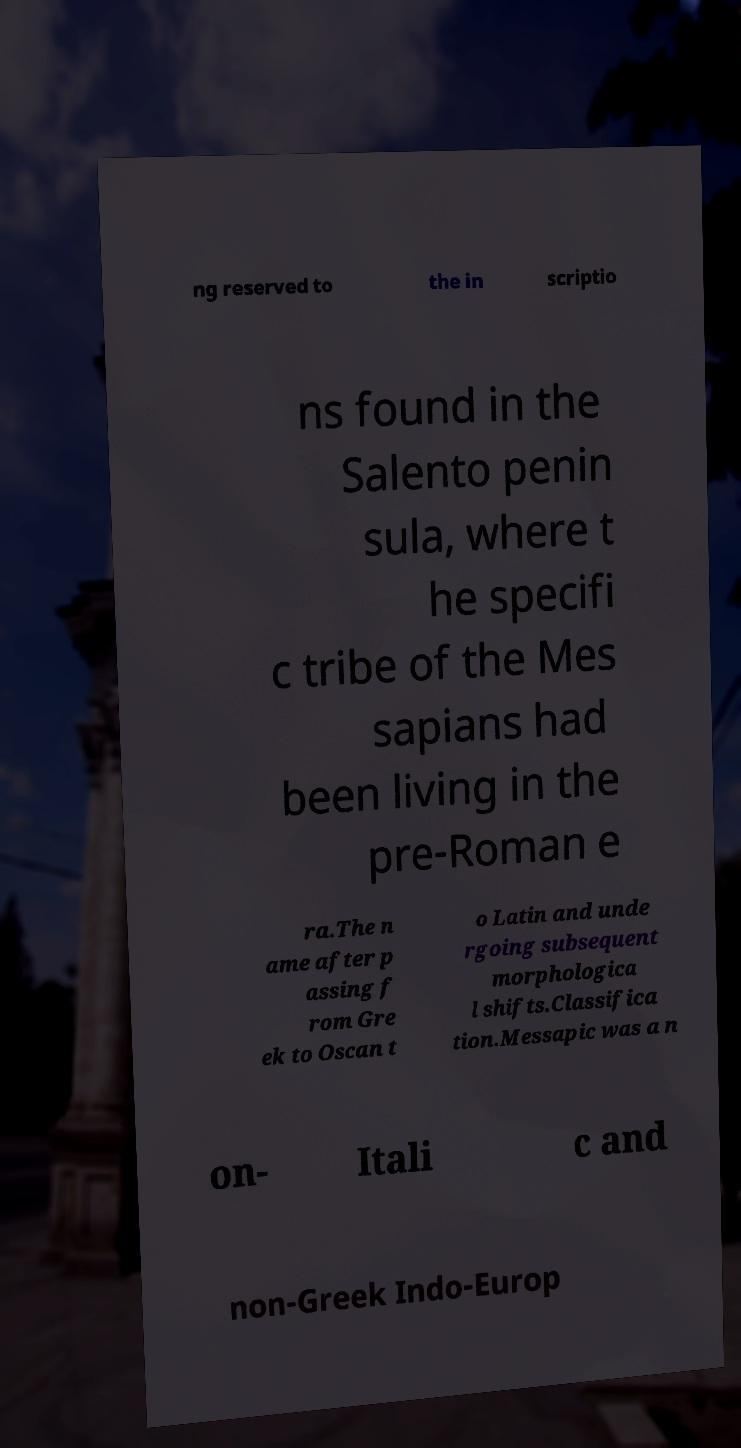What messages or text are displayed in this image? I need them in a readable, typed format. ng reserved to the in scriptio ns found in the Salento penin sula, where t he specifi c tribe of the Mes sapians had been living in the pre-Roman e ra.The n ame after p assing f rom Gre ek to Oscan t o Latin and unde rgoing subsequent morphologica l shifts.Classifica tion.Messapic was a n on- Itali c and non-Greek Indo-Europ 